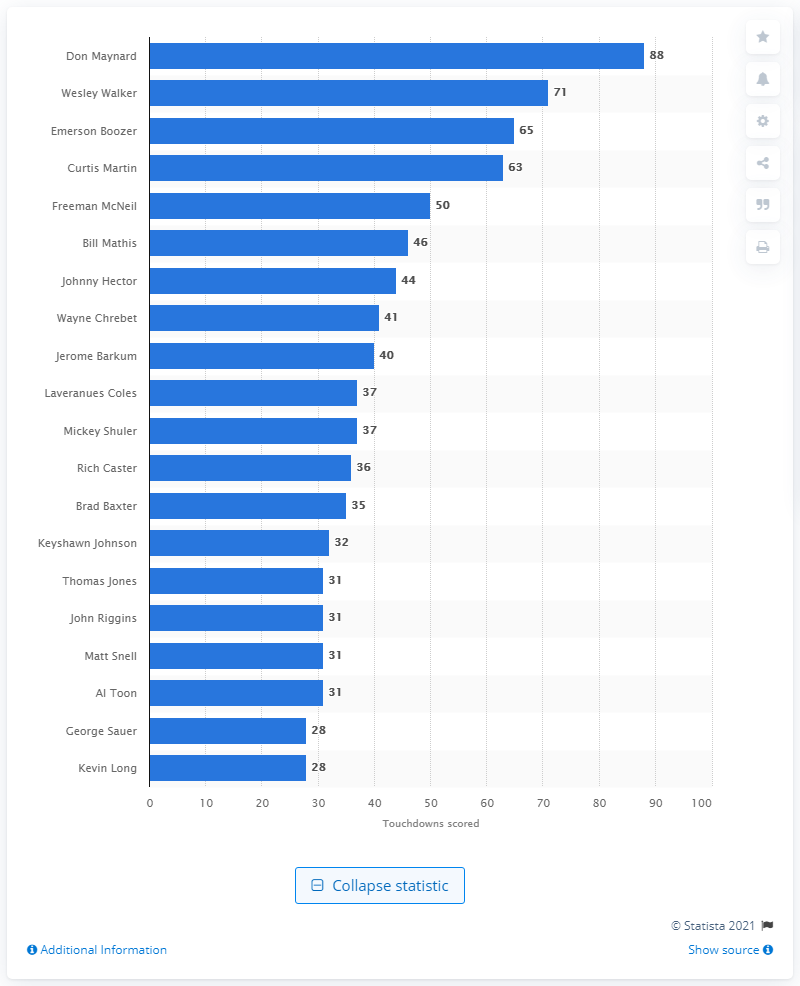Mention a couple of crucial points in this snapshot. Don Maynard is the career touchdown leader of the New York Jets. 